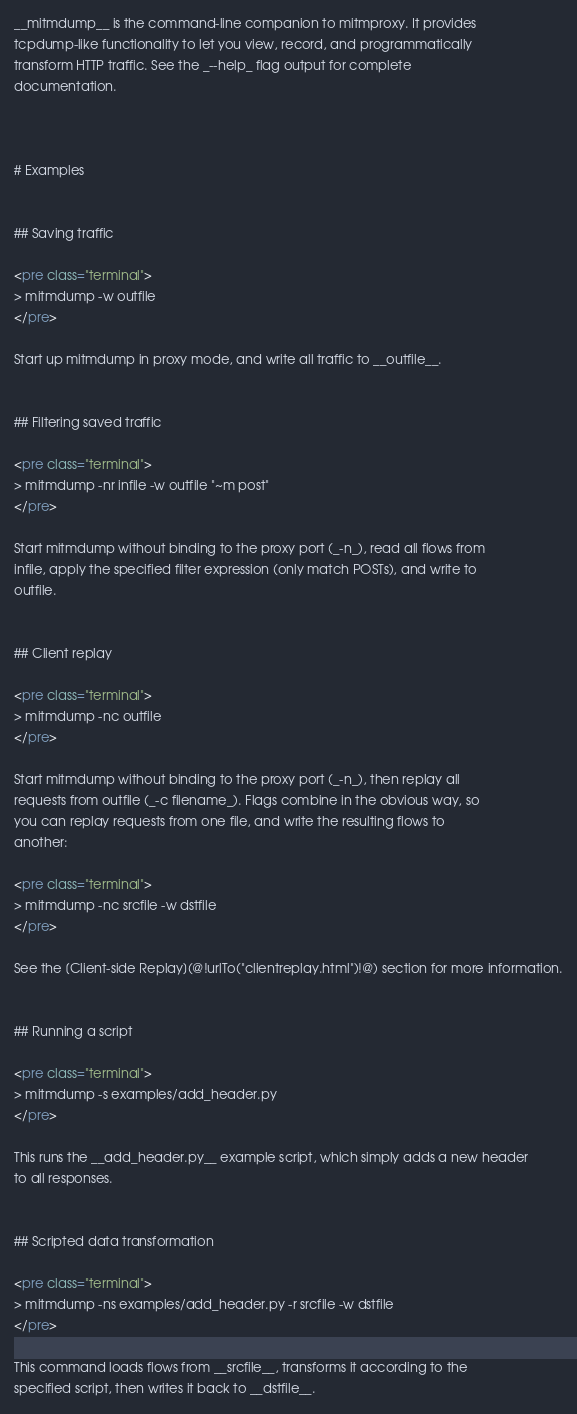Convert code to text. <code><loc_0><loc_0><loc_500><loc_500><_HTML_>
__mitmdump__ is the command-line companion to mitmproxy. It provides
tcpdump-like functionality to let you view, record, and programmatically
transform HTTP traffic. See the _--help_ flag output for complete
documentation.



# Examples


## Saving traffic

<pre class="terminal">
> mitmdump -w outfile
</pre>

Start up mitmdump in proxy mode, and write all traffic to __outfile__. 


## Filtering saved traffic

<pre class="terminal">
> mitmdump -nr infile -w outfile "~m post"
</pre>

Start mitmdump without binding to the proxy port (_-n_), read all flows from
infile, apply the specified filter expression (only match POSTs), and write to
outfile.


## Client replay

<pre class="terminal">
> mitmdump -nc outfile
</pre>

Start mitmdump without binding to the proxy port (_-n_), then replay all
requests from outfile (_-c filename_). Flags combine in the obvious way, so
you can replay requests from one file, and write the resulting flows to
another:

<pre class="terminal">
> mitmdump -nc srcfile -w dstfile
</pre>

See the [Client-side Replay](@!urlTo("clientreplay.html")!@) section for more information.


## Running a script

<pre class="terminal">
> mitmdump -s examples/add_header.py
</pre>

This runs the __add_header.py__ example script, which simply adds a new header
to all responses.


## Scripted data transformation

<pre class="terminal">
> mitmdump -ns examples/add_header.py -r srcfile -w dstfile
</pre>

This command loads flows from __srcfile__, transforms it according to the
specified script, then writes it back to __dstfile__.

</code> 